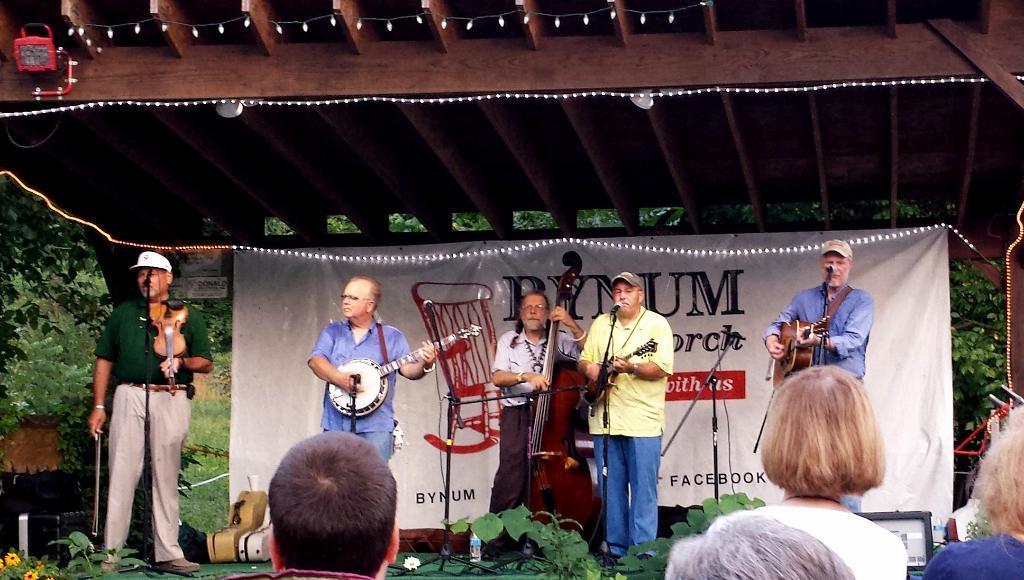In one or two sentences, can you explain what this image depicts? This picture is clicked in a musical concert. There are four men playing musical instruments, three of them are playing guitar and singing on microphone. The man on the left corner of the picture is playing guitar and in the middle, the man in white shirt is holding guitar in his hands and playing it and behind them, we see a banner which have some text written on it. Behind them, we see trees. On the top of the picture, we see the roof of the concert. 